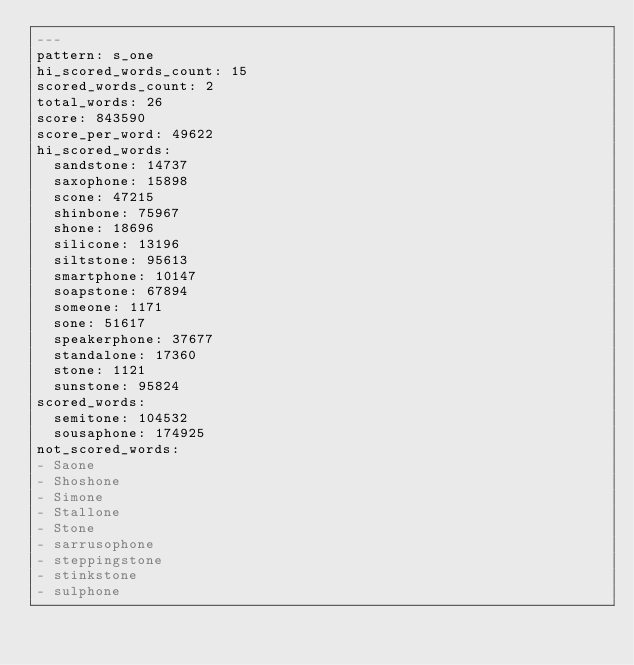Convert code to text. <code><loc_0><loc_0><loc_500><loc_500><_YAML_>---
pattern: s_one
hi_scored_words_count: 15
scored_words_count: 2
total_words: 26
score: 843590
score_per_word: 49622
hi_scored_words:
  sandstone: 14737
  saxophone: 15898
  scone: 47215
  shinbone: 75967
  shone: 18696
  silicone: 13196
  siltstone: 95613
  smartphone: 10147
  soapstone: 67894
  someone: 1171
  sone: 51617
  speakerphone: 37677
  standalone: 17360
  stone: 1121
  sunstone: 95824
scored_words:
  semitone: 104532
  sousaphone: 174925
not_scored_words:
- Saone
- Shoshone
- Simone
- Stallone
- Stone
- sarrusophone
- steppingstone
- stinkstone
- sulphone
</code> 